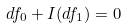<formula> <loc_0><loc_0><loc_500><loc_500>d f _ { 0 } + I ( d f _ { 1 } ) = 0</formula> 